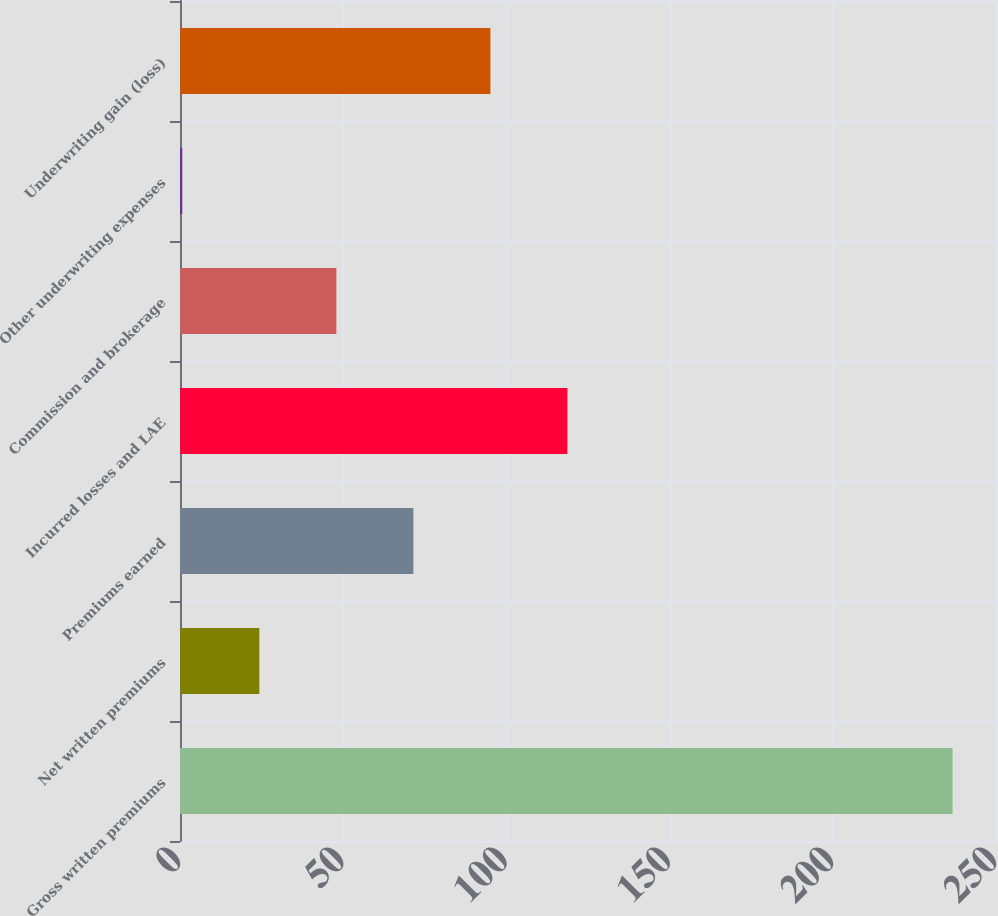Convert chart to OTSL. <chart><loc_0><loc_0><loc_500><loc_500><bar_chart><fcel>Gross written premiums<fcel>Net written premiums<fcel>Premiums earned<fcel>Incurred losses and LAE<fcel>Commission and brokerage<fcel>Other underwriting expenses<fcel>Underwriting gain (loss)<nl><fcel>236.7<fcel>24.3<fcel>71.5<fcel>118.7<fcel>47.9<fcel>0.7<fcel>95.1<nl></chart> 